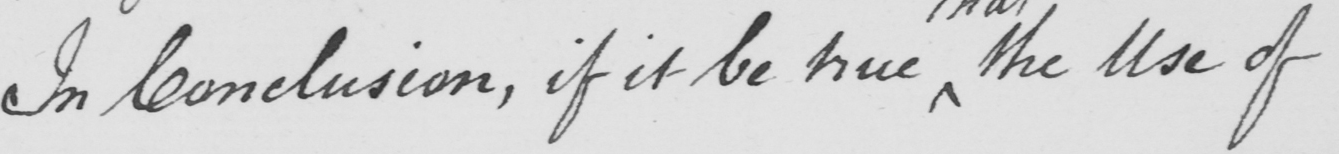Can you tell me what this handwritten text says? In Conclusion , if it be true the Use of 